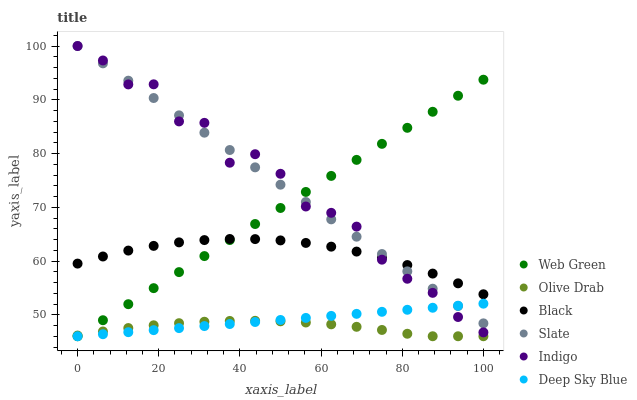Does Olive Drab have the minimum area under the curve?
Answer yes or no. Yes. Does Indigo have the maximum area under the curve?
Answer yes or no. Yes. Does Slate have the minimum area under the curve?
Answer yes or no. No. Does Slate have the maximum area under the curve?
Answer yes or no. No. Is Deep Sky Blue the smoothest?
Answer yes or no. Yes. Is Indigo the roughest?
Answer yes or no. Yes. Is Slate the smoothest?
Answer yes or no. No. Is Slate the roughest?
Answer yes or no. No. Does Web Green have the lowest value?
Answer yes or no. Yes. Does Slate have the lowest value?
Answer yes or no. No. Does Slate have the highest value?
Answer yes or no. Yes. Does Web Green have the highest value?
Answer yes or no. No. Is Olive Drab less than Black?
Answer yes or no. Yes. Is Black greater than Deep Sky Blue?
Answer yes or no. Yes. Does Olive Drab intersect Web Green?
Answer yes or no. Yes. Is Olive Drab less than Web Green?
Answer yes or no. No. Is Olive Drab greater than Web Green?
Answer yes or no. No. Does Olive Drab intersect Black?
Answer yes or no. No. 